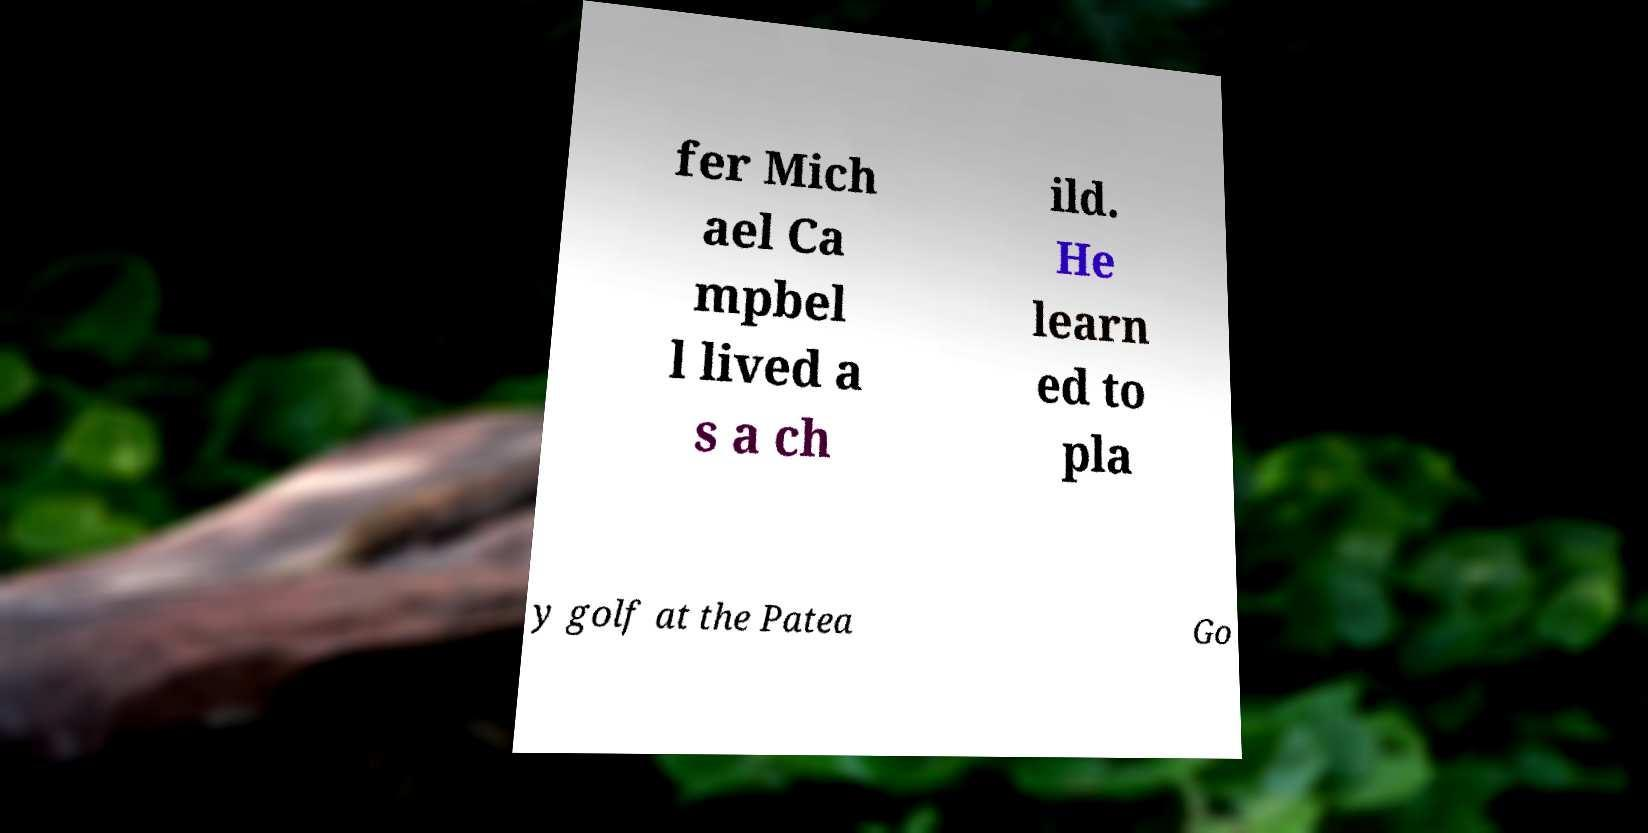Please identify and transcribe the text found in this image. fer Mich ael Ca mpbel l lived a s a ch ild. He learn ed to pla y golf at the Patea Go 